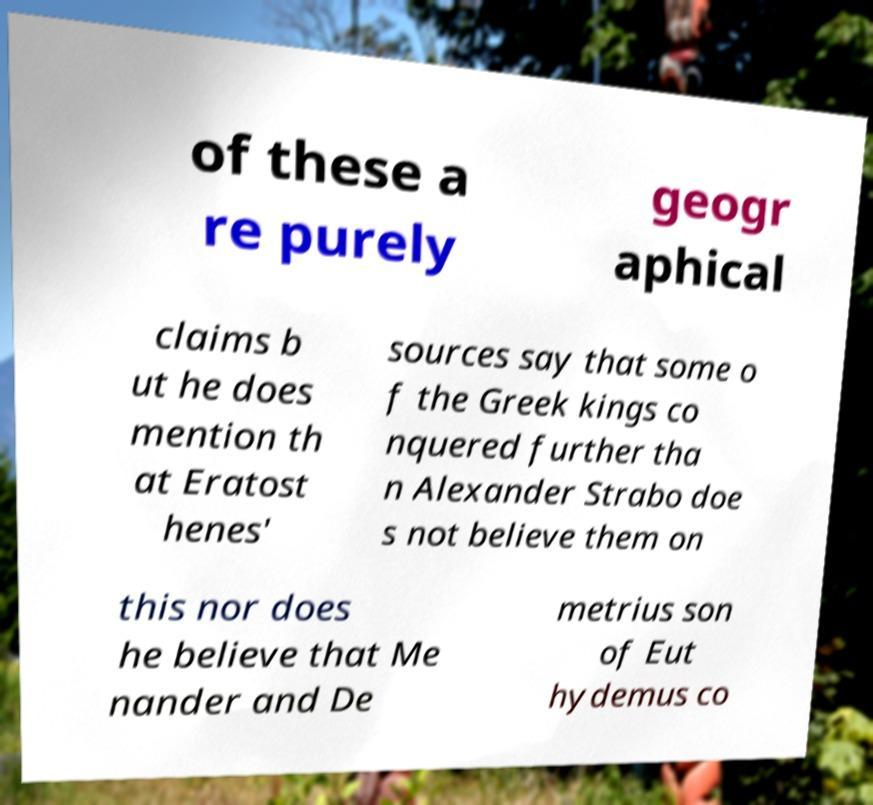I need the written content from this picture converted into text. Can you do that? of these a re purely geogr aphical claims b ut he does mention th at Eratost henes' sources say that some o f the Greek kings co nquered further tha n Alexander Strabo doe s not believe them on this nor does he believe that Me nander and De metrius son of Eut hydemus co 